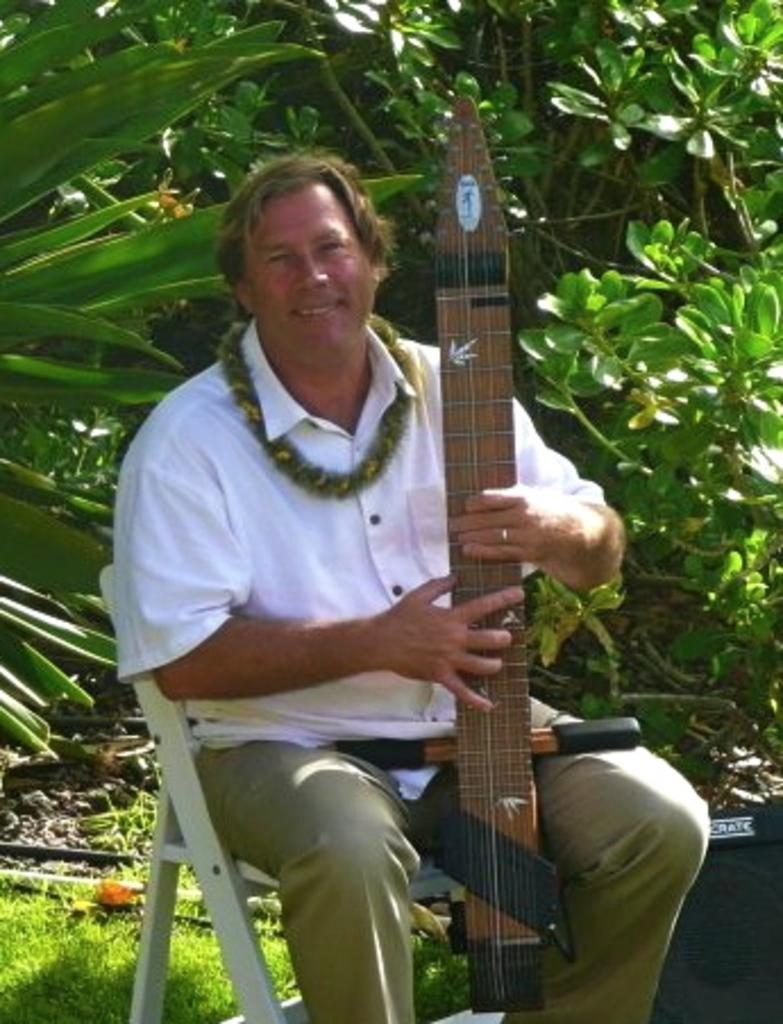Who is the main subject in the image? There is a man in the image. What is the man doing in the image? The man is sitting on a chair and holding a musical instrument. What can be seen in the background of the image? There are trees in the background of the image. What channel is the man watching on the television in the image? There is no television present in the image; the man is holding a musical instrument. What type of oven can be seen in the image? There is no oven present in the image. 